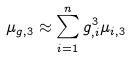Convert formula to latex. <formula><loc_0><loc_0><loc_500><loc_500>\mu _ { g , 3 } \approx \sum _ { i = 1 } ^ { n } g _ { , i } ^ { 3 } \mu _ { i , 3 }</formula> 